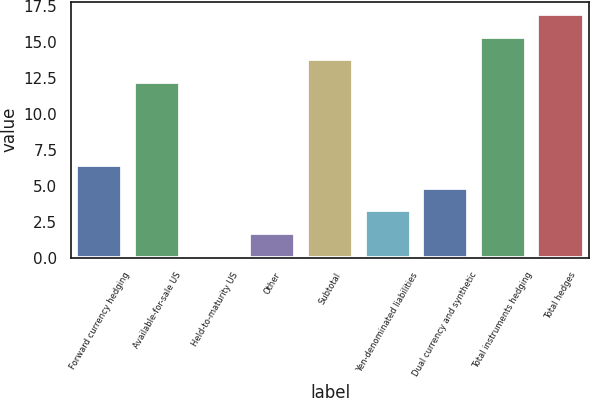Convert chart to OTSL. <chart><loc_0><loc_0><loc_500><loc_500><bar_chart><fcel>Forward currency hedging<fcel>Available-for-sale US<fcel>Held-to-maturity US<fcel>Other<fcel>Subtotal<fcel>Yen-denominated liabilities<fcel>Dual currency and synthetic<fcel>Total instruments hedging<fcel>Total hedges<nl><fcel>6.46<fcel>12.2<fcel>0.1<fcel>1.69<fcel>13.79<fcel>3.28<fcel>4.87<fcel>15.38<fcel>16.97<nl></chart> 